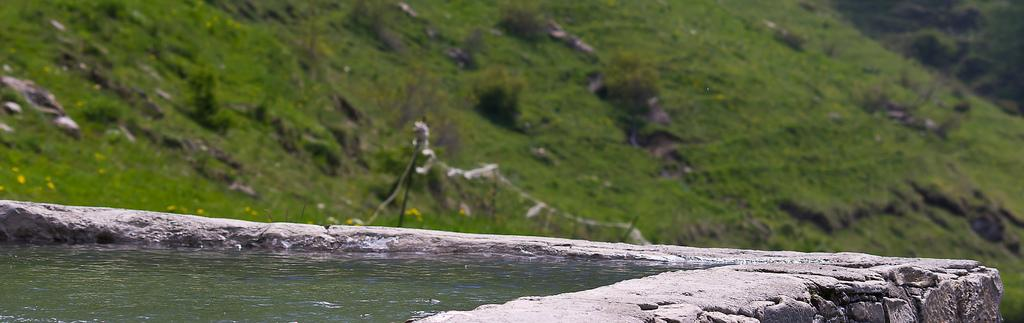What is visible in the image? Water is visible in the image. What can be seen in the background of the image? There are trees and grass in the background of the image. What is the color of the trees and grass? The trees and grass are green in color. How many buckets of water can be seen in the image? There are no buckets present in the image. What type of sail can be seen on the trees in the image? There are no sails present in the image, as it features trees and grass in the background. 